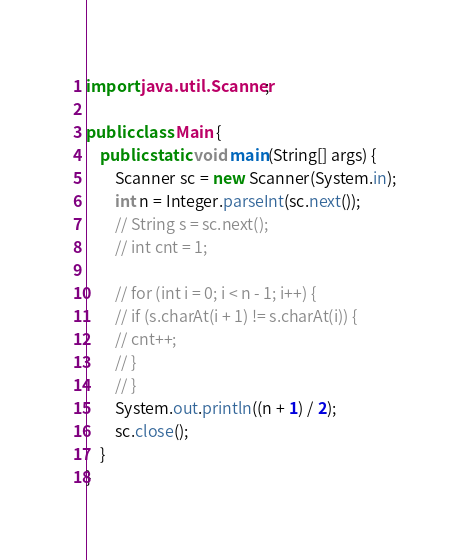Convert code to text. <code><loc_0><loc_0><loc_500><loc_500><_Java_>import java.util.Scanner;

public class Main {
    public static void main(String[] args) {
        Scanner sc = new Scanner(System.in);
        int n = Integer.parseInt(sc.next());
        // String s = sc.next();
        // int cnt = 1;

        // for (int i = 0; i < n - 1; i++) {
        // if (s.charAt(i + 1) != s.charAt(i)) {
        // cnt++;
        // }
        // }
        System.out.println((n + 1) / 2);
        sc.close();
    }
}</code> 